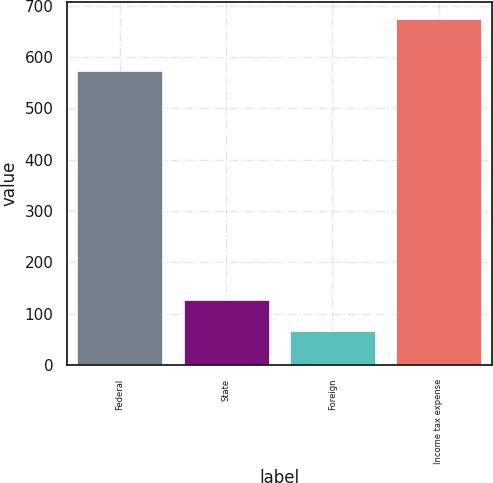Convert chart to OTSL. <chart><loc_0><loc_0><loc_500><loc_500><bar_chart><fcel>Federal<fcel>State<fcel>Foreign<fcel>Income tax expense<nl><fcel>573<fcel>126.8<fcel>66<fcel>674<nl></chart> 